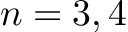<formula> <loc_0><loc_0><loc_500><loc_500>n = 3 , 4</formula> 